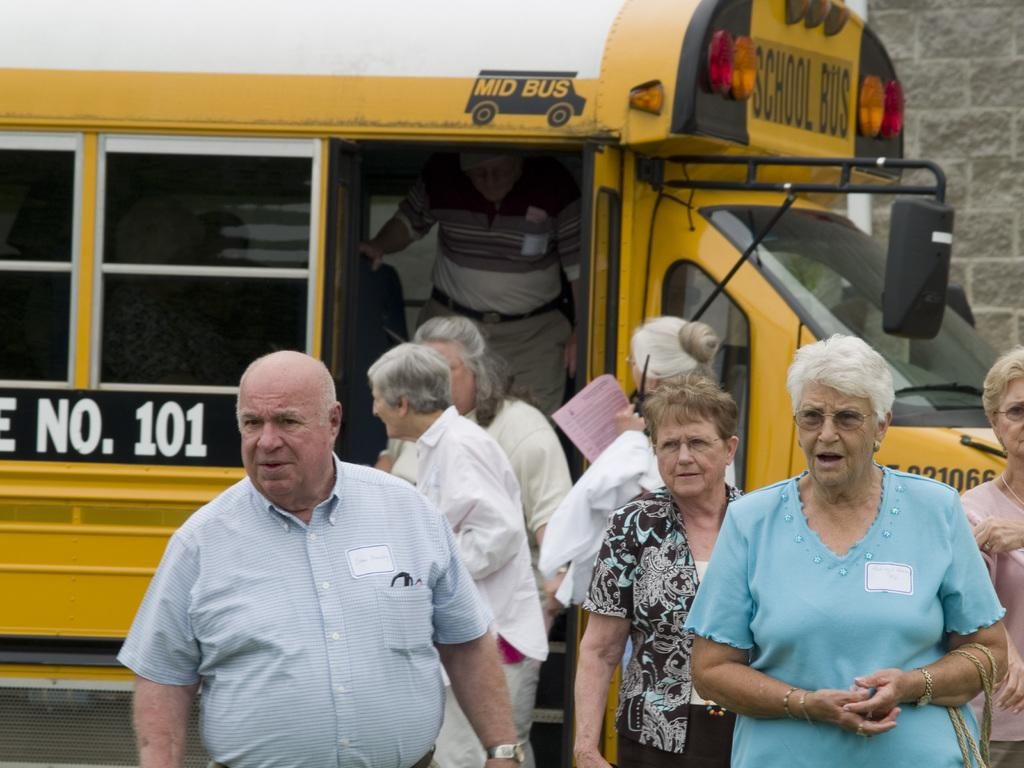Who or what can be seen in the image? There are people in the image. What else is present in the image besides the people? There is a vehicle in the image. What can be seen in the background of the image? There is a wall in the background of the image. What type of thread is being used to sew the knee of the person in the image? There is no indication in the image that anyone's knee is being sewn or that thread is being used. 